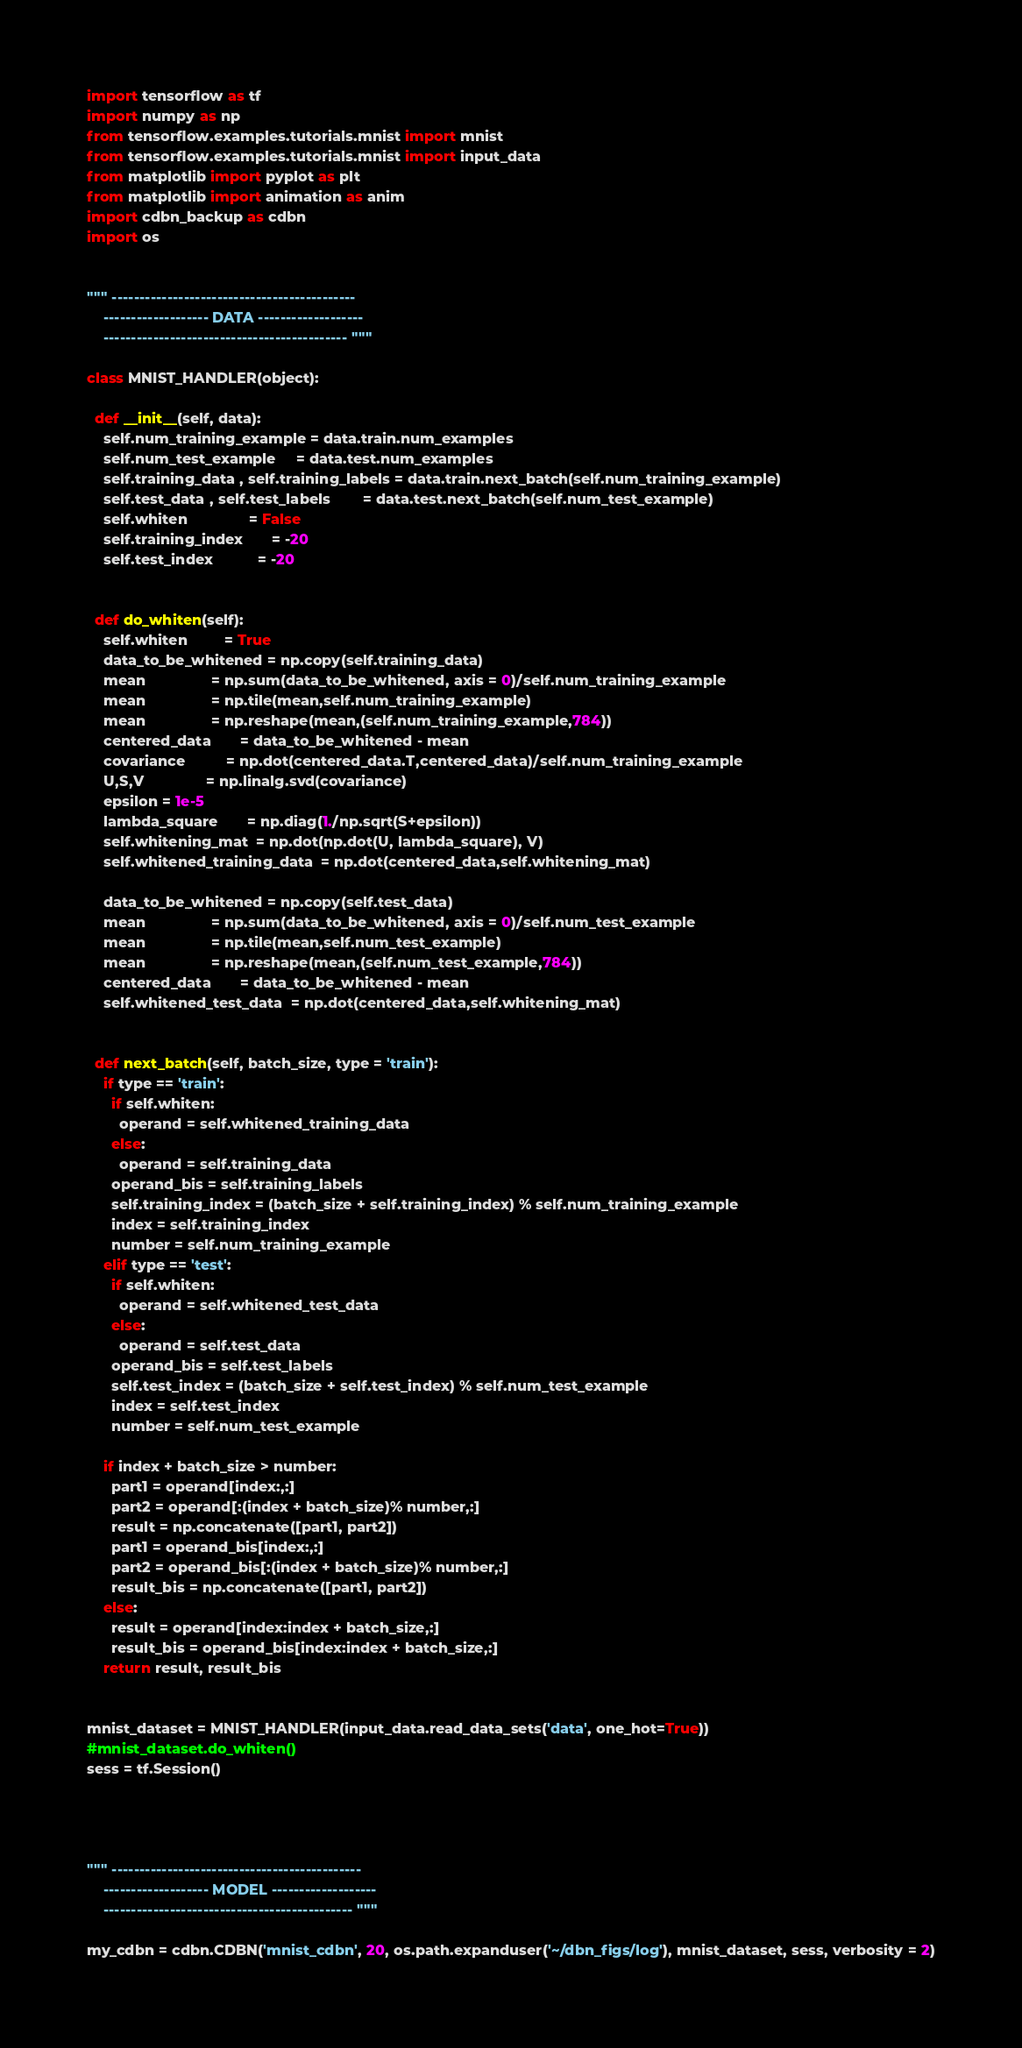<code> <loc_0><loc_0><loc_500><loc_500><_Python_>import tensorflow as tf
import numpy as np
from tensorflow.examples.tutorials.mnist import mnist
from tensorflow.examples.tutorials.mnist import input_data
from matplotlib import pyplot as plt
from matplotlib import animation as anim
import cdbn_backup as cdbn
import os


""" --------------------------------------------
    ------------------- DATA -------------------
    -------------------------------------------- """

class MNIST_HANDLER(object):
  
  def __init__(self, data):
    self.num_training_example = data.train.num_examples
    self.num_test_example     = data.test.num_examples
    self.training_data , self.training_labels = data.train.next_batch(self.num_training_example)
    self.test_data , self.test_labels        = data.test.next_batch(self.num_test_example)
    self.whiten               = False
    self.training_index       = -20
    self.test_index           = -20
    
    
  def do_whiten(self):
    self.whiten         = True
    data_to_be_whitened = np.copy(self.training_data)
    mean                = np.sum(data_to_be_whitened, axis = 0)/self.num_training_example
    mean                = np.tile(mean,self.num_training_example)
    mean                = np.reshape(mean,(self.num_training_example,784))
    centered_data       = data_to_be_whitened - mean                
    covariance          = np.dot(centered_data.T,centered_data)/self.num_training_example
    U,S,V               = np.linalg.svd(covariance)
    epsilon = 1e-5
    lambda_square       = np.diag(1./np.sqrt(S+epsilon))
    self.whitening_mat  = np.dot(np.dot(U, lambda_square), V)    
    self.whitened_training_data  = np.dot(centered_data,self.whitening_mat)
    
    data_to_be_whitened = np.copy(self.test_data)
    mean                = np.sum(data_to_be_whitened, axis = 0)/self.num_test_example
    mean                = np.tile(mean,self.num_test_example)
    mean                = np.reshape(mean,(self.num_test_example,784))
    centered_data       = data_to_be_whitened - mean  
    self.whitened_test_data  = np.dot(centered_data,self.whitening_mat)

    
  def next_batch(self, batch_size, type = 'train'):
    if type == 'train':
      if self.whiten:
        operand = self.whitened_training_data
      else:
        operand = self.training_data
      operand_bis = self.training_labels
      self.training_index = (batch_size + self.training_index) % self.num_training_example
      index = self.training_index
      number = self.num_training_example
    elif type == 'test':
      if self.whiten:
        operand = self.whitened_test_data
      else:
        operand = self.test_data
      operand_bis = self.test_labels
      self.test_index = (batch_size + self.test_index) % self.num_test_example
      index = self.test_index
      number = self.num_test_example

    if index + batch_size > number:
      part1 = operand[index:,:]
      part2 = operand[:(index + batch_size)% number,:]
      result = np.concatenate([part1, part2])
      part1 = operand_bis[index:,:]
      part2 = operand_bis[:(index + batch_size)% number,:]
      result_bis = np.concatenate([part1, part2])
    else:
      result = operand[index:index + batch_size,:]
      result_bis = operand_bis[index:index + batch_size,:]
    return result, result_bis
        

mnist_dataset = MNIST_HANDLER(input_data.read_data_sets('data', one_hot=True))
#mnist_dataset.do_whiten()
sess = tf.Session()




""" ---------------------------------------------
    ------------------- MODEL -------------------
    --------------------------------------------- """

my_cdbn = cdbn.CDBN('mnist_cdbn', 20, os.path.expanduser('~/dbn_figs/log'), mnist_dataset, sess, verbosity = 2)
</code> 